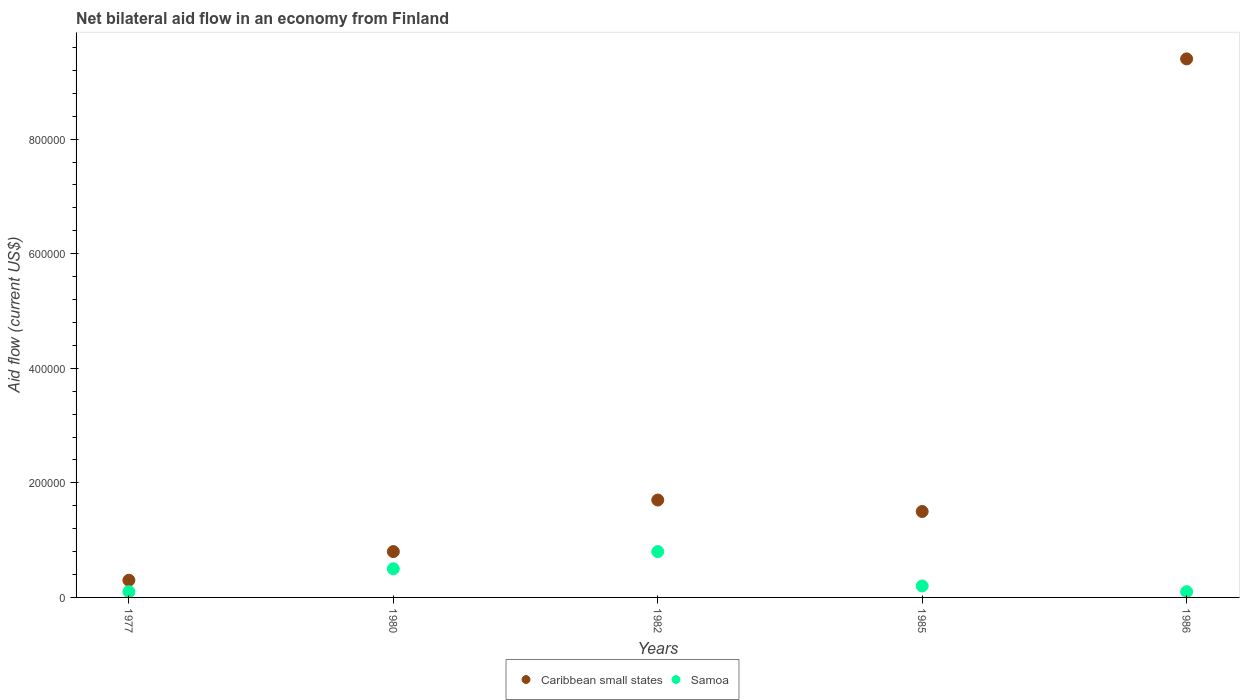How many different coloured dotlines are there?
Provide a succinct answer. 2. Is the number of dotlines equal to the number of legend labels?
Your answer should be very brief. Yes. What is the net bilateral aid flow in Caribbean small states in 1985?
Your response must be concise. 1.50e+05. Across all years, what is the maximum net bilateral aid flow in Caribbean small states?
Keep it short and to the point. 9.40e+05. In which year was the net bilateral aid flow in Caribbean small states maximum?
Your answer should be very brief. 1986. In which year was the net bilateral aid flow in Samoa minimum?
Offer a very short reply. 1977. What is the total net bilateral aid flow in Samoa in the graph?
Make the answer very short. 1.70e+05. What is the difference between the net bilateral aid flow in Caribbean small states in 1977 and that in 1980?
Offer a terse response. -5.00e+04. What is the difference between the net bilateral aid flow in Samoa in 1986 and the net bilateral aid flow in Caribbean small states in 1980?
Offer a terse response. -7.00e+04. What is the average net bilateral aid flow in Samoa per year?
Make the answer very short. 3.40e+04. In how many years, is the net bilateral aid flow in Caribbean small states greater than 600000 US$?
Provide a succinct answer. 1. What is the ratio of the net bilateral aid flow in Caribbean small states in 1982 to that in 1985?
Keep it short and to the point. 1.13. Is the difference between the net bilateral aid flow in Samoa in 1977 and 1982 greater than the difference between the net bilateral aid flow in Caribbean small states in 1977 and 1982?
Ensure brevity in your answer.  Yes. In how many years, is the net bilateral aid flow in Caribbean small states greater than the average net bilateral aid flow in Caribbean small states taken over all years?
Provide a succinct answer. 1. Is the net bilateral aid flow in Samoa strictly greater than the net bilateral aid flow in Caribbean small states over the years?
Your response must be concise. No. Is the net bilateral aid flow in Samoa strictly less than the net bilateral aid flow in Caribbean small states over the years?
Your answer should be very brief. Yes. How many dotlines are there?
Give a very brief answer. 2. How many years are there in the graph?
Provide a succinct answer. 5. What is the difference between two consecutive major ticks on the Y-axis?
Make the answer very short. 2.00e+05. Are the values on the major ticks of Y-axis written in scientific E-notation?
Your answer should be very brief. No. Does the graph contain any zero values?
Your answer should be compact. No. Does the graph contain grids?
Provide a short and direct response. No. Where does the legend appear in the graph?
Your answer should be compact. Bottom center. What is the title of the graph?
Provide a short and direct response. Net bilateral aid flow in an economy from Finland. What is the label or title of the Y-axis?
Offer a very short reply. Aid flow (current US$). What is the Aid flow (current US$) in Caribbean small states in 1980?
Offer a terse response. 8.00e+04. What is the Aid flow (current US$) of Samoa in 1980?
Offer a terse response. 5.00e+04. What is the Aid flow (current US$) in Caribbean small states in 1982?
Your response must be concise. 1.70e+05. What is the Aid flow (current US$) in Samoa in 1985?
Your answer should be very brief. 2.00e+04. What is the Aid flow (current US$) in Caribbean small states in 1986?
Ensure brevity in your answer.  9.40e+05. Across all years, what is the maximum Aid flow (current US$) of Caribbean small states?
Ensure brevity in your answer.  9.40e+05. Across all years, what is the minimum Aid flow (current US$) of Caribbean small states?
Your answer should be compact. 3.00e+04. Across all years, what is the minimum Aid flow (current US$) of Samoa?
Give a very brief answer. 10000. What is the total Aid flow (current US$) of Caribbean small states in the graph?
Ensure brevity in your answer.  1.37e+06. What is the difference between the Aid flow (current US$) in Caribbean small states in 1977 and that in 1980?
Your answer should be compact. -5.00e+04. What is the difference between the Aid flow (current US$) of Samoa in 1977 and that in 1980?
Give a very brief answer. -4.00e+04. What is the difference between the Aid flow (current US$) of Samoa in 1977 and that in 1982?
Make the answer very short. -7.00e+04. What is the difference between the Aid flow (current US$) of Caribbean small states in 1977 and that in 1985?
Provide a short and direct response. -1.20e+05. What is the difference between the Aid flow (current US$) of Samoa in 1977 and that in 1985?
Make the answer very short. -10000. What is the difference between the Aid flow (current US$) of Caribbean small states in 1977 and that in 1986?
Ensure brevity in your answer.  -9.10e+05. What is the difference between the Aid flow (current US$) in Samoa in 1980 and that in 1982?
Your response must be concise. -3.00e+04. What is the difference between the Aid flow (current US$) of Samoa in 1980 and that in 1985?
Provide a short and direct response. 3.00e+04. What is the difference between the Aid flow (current US$) in Caribbean small states in 1980 and that in 1986?
Your answer should be compact. -8.60e+05. What is the difference between the Aid flow (current US$) in Caribbean small states in 1982 and that in 1985?
Your answer should be very brief. 2.00e+04. What is the difference between the Aid flow (current US$) of Caribbean small states in 1982 and that in 1986?
Ensure brevity in your answer.  -7.70e+05. What is the difference between the Aid flow (current US$) of Samoa in 1982 and that in 1986?
Your response must be concise. 7.00e+04. What is the difference between the Aid flow (current US$) in Caribbean small states in 1985 and that in 1986?
Ensure brevity in your answer.  -7.90e+05. What is the difference between the Aid flow (current US$) of Samoa in 1985 and that in 1986?
Ensure brevity in your answer.  10000. What is the difference between the Aid flow (current US$) of Caribbean small states in 1977 and the Aid flow (current US$) of Samoa in 1985?
Ensure brevity in your answer.  10000. What is the difference between the Aid flow (current US$) of Caribbean small states in 1977 and the Aid flow (current US$) of Samoa in 1986?
Make the answer very short. 2.00e+04. What is the difference between the Aid flow (current US$) of Caribbean small states in 1980 and the Aid flow (current US$) of Samoa in 1982?
Your answer should be very brief. 0. What is the difference between the Aid flow (current US$) in Caribbean small states in 1982 and the Aid flow (current US$) in Samoa in 1986?
Keep it short and to the point. 1.60e+05. What is the difference between the Aid flow (current US$) of Caribbean small states in 1985 and the Aid flow (current US$) of Samoa in 1986?
Your response must be concise. 1.40e+05. What is the average Aid flow (current US$) in Caribbean small states per year?
Your answer should be very brief. 2.74e+05. What is the average Aid flow (current US$) in Samoa per year?
Give a very brief answer. 3.40e+04. In the year 1977, what is the difference between the Aid flow (current US$) in Caribbean small states and Aid flow (current US$) in Samoa?
Ensure brevity in your answer.  2.00e+04. In the year 1982, what is the difference between the Aid flow (current US$) in Caribbean small states and Aid flow (current US$) in Samoa?
Ensure brevity in your answer.  9.00e+04. In the year 1985, what is the difference between the Aid flow (current US$) of Caribbean small states and Aid flow (current US$) of Samoa?
Give a very brief answer. 1.30e+05. In the year 1986, what is the difference between the Aid flow (current US$) of Caribbean small states and Aid flow (current US$) of Samoa?
Provide a succinct answer. 9.30e+05. What is the ratio of the Aid flow (current US$) in Caribbean small states in 1977 to that in 1980?
Your answer should be compact. 0.38. What is the ratio of the Aid flow (current US$) in Caribbean small states in 1977 to that in 1982?
Your answer should be compact. 0.18. What is the ratio of the Aid flow (current US$) of Samoa in 1977 to that in 1982?
Offer a terse response. 0.12. What is the ratio of the Aid flow (current US$) of Caribbean small states in 1977 to that in 1985?
Your response must be concise. 0.2. What is the ratio of the Aid flow (current US$) of Samoa in 1977 to that in 1985?
Offer a terse response. 0.5. What is the ratio of the Aid flow (current US$) in Caribbean small states in 1977 to that in 1986?
Make the answer very short. 0.03. What is the ratio of the Aid flow (current US$) in Caribbean small states in 1980 to that in 1982?
Offer a terse response. 0.47. What is the ratio of the Aid flow (current US$) of Caribbean small states in 1980 to that in 1985?
Offer a very short reply. 0.53. What is the ratio of the Aid flow (current US$) of Samoa in 1980 to that in 1985?
Keep it short and to the point. 2.5. What is the ratio of the Aid flow (current US$) of Caribbean small states in 1980 to that in 1986?
Ensure brevity in your answer.  0.09. What is the ratio of the Aid flow (current US$) of Samoa in 1980 to that in 1986?
Provide a succinct answer. 5. What is the ratio of the Aid flow (current US$) of Caribbean small states in 1982 to that in 1985?
Give a very brief answer. 1.13. What is the ratio of the Aid flow (current US$) in Samoa in 1982 to that in 1985?
Your answer should be compact. 4. What is the ratio of the Aid flow (current US$) of Caribbean small states in 1982 to that in 1986?
Provide a short and direct response. 0.18. What is the ratio of the Aid flow (current US$) of Caribbean small states in 1985 to that in 1986?
Offer a very short reply. 0.16. What is the difference between the highest and the second highest Aid flow (current US$) of Caribbean small states?
Your answer should be very brief. 7.70e+05. What is the difference between the highest and the lowest Aid flow (current US$) in Caribbean small states?
Offer a terse response. 9.10e+05. 